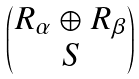<formula> <loc_0><loc_0><loc_500><loc_500>\begin{pmatrix} R _ { \alpha } \oplus R _ { \beta } \\ S \end{pmatrix}</formula> 